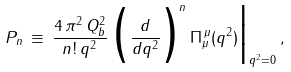<formula> <loc_0><loc_0><loc_500><loc_500>P _ { n } \, \equiv \, \frac { 4 \, \pi ^ { 2 } \, Q _ { b } ^ { 2 } } { n ! \, q ^ { 2 } } \, \Big ( \frac { d } { d q ^ { 2 } } \Big ) ^ { n } \, \Pi _ { \mu } ^ { \, \mu } ( q ^ { 2 } ) \Big | _ { q ^ { 2 } = 0 } \, ,</formula> 